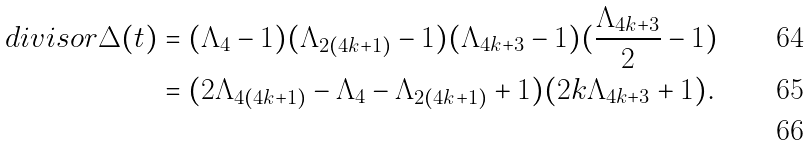Convert formula to latex. <formula><loc_0><loc_0><loc_500><loc_500>d i v i s o r \Delta ( t ) & = ( \Lambda _ { 4 } - 1 ) ( \Lambda _ { 2 ( 4 k + 1 ) } - 1 ) ( \Lambda _ { 4 k + 3 } - 1 ) ( \frac { \Lambda _ { 4 k + 3 } } { 2 } - 1 ) \\ & = ( 2 \Lambda _ { 4 ( 4 k + 1 ) } - \Lambda _ { 4 } - \Lambda _ { 2 ( 4 k + 1 ) } + 1 ) ( 2 k \Lambda _ { 4 k + 3 } + 1 ) . \\</formula> 